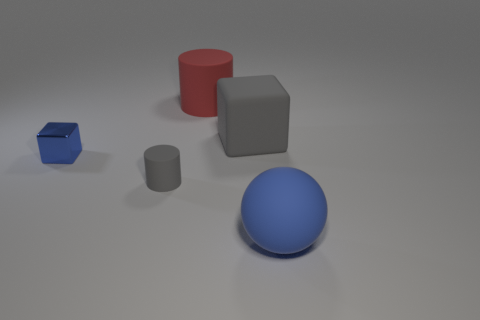Add 2 tiny yellow matte balls. How many objects exist? 7 Subtract all cylinders. How many objects are left? 3 Add 2 small gray matte things. How many small gray matte things exist? 3 Subtract 0 brown cubes. How many objects are left? 5 Subtract all large balls. Subtract all large blue cubes. How many objects are left? 4 Add 1 metal cubes. How many metal cubes are left? 2 